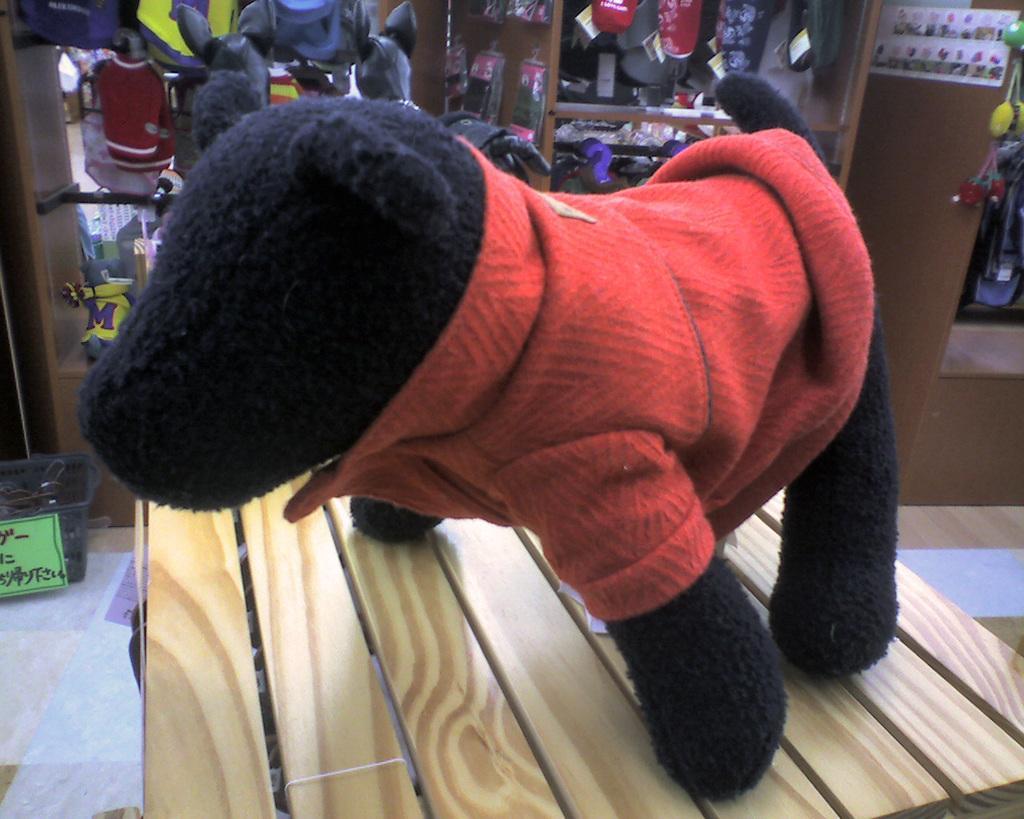In one or two sentences, can you explain what this image depicts? In this image I can see a black and red color toy. It is on the brown surface. Back I can see few objects. 